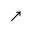Convert formula to latex. <formula><loc_0><loc_0><loc_500><loc_500>\nearrow</formula> 